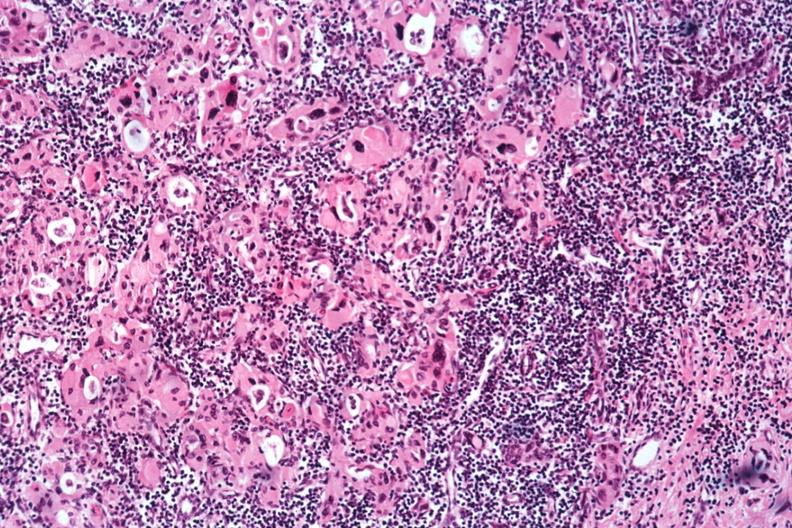where is this part in the figure?
Answer the question using a single word or phrase. Endocrine system 